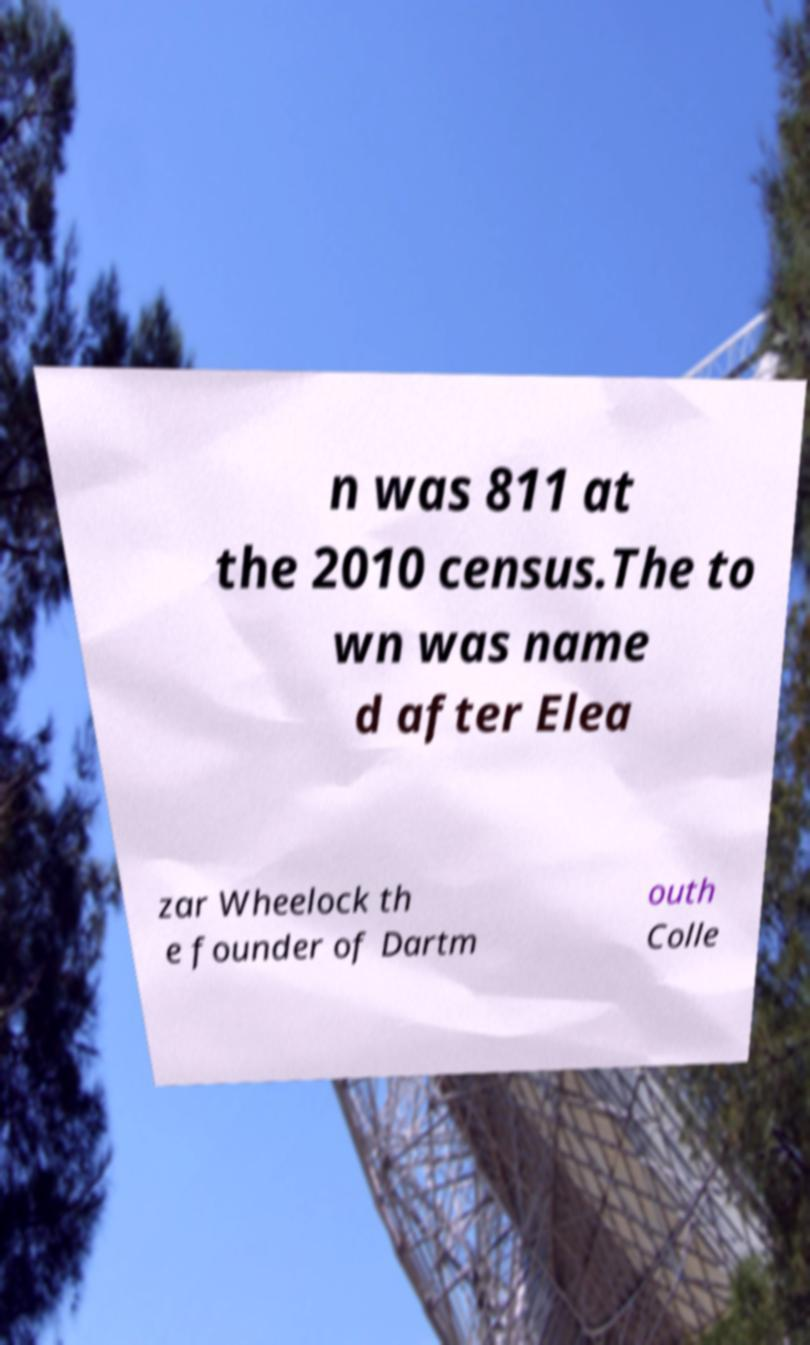Please identify and transcribe the text found in this image. n was 811 at the 2010 census.The to wn was name d after Elea zar Wheelock th e founder of Dartm outh Colle 